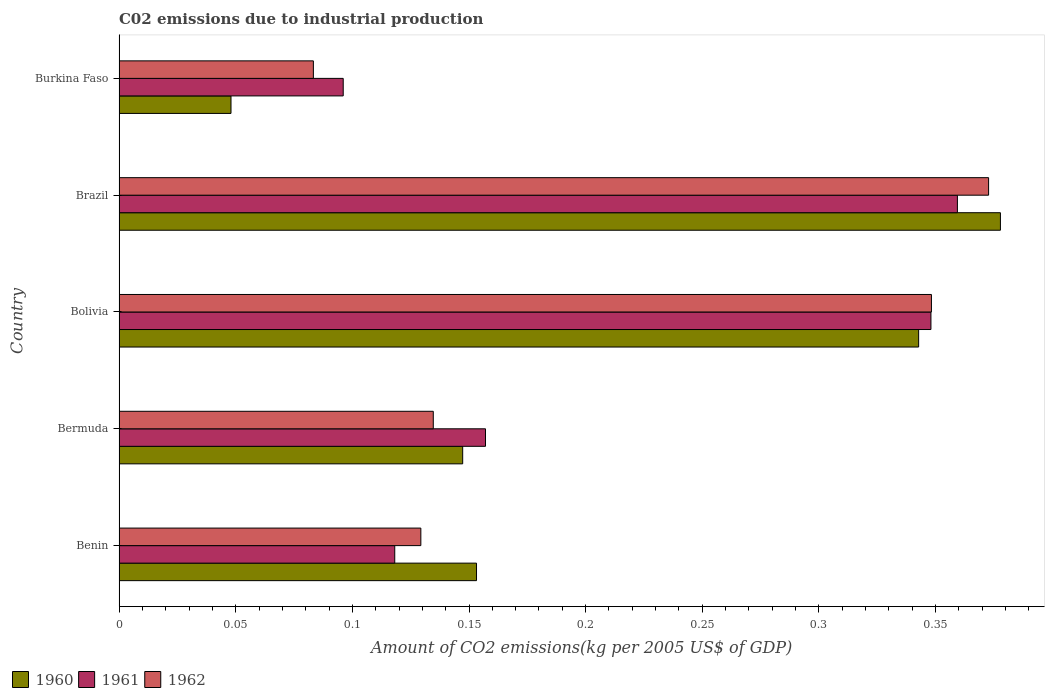How many different coloured bars are there?
Ensure brevity in your answer.  3. How many groups of bars are there?
Your answer should be very brief. 5. Are the number of bars on each tick of the Y-axis equal?
Your answer should be very brief. Yes. How many bars are there on the 4th tick from the top?
Keep it short and to the point. 3. What is the amount of CO2 emitted due to industrial production in 1962 in Bolivia?
Your answer should be very brief. 0.35. Across all countries, what is the maximum amount of CO2 emitted due to industrial production in 1962?
Give a very brief answer. 0.37. Across all countries, what is the minimum amount of CO2 emitted due to industrial production in 1961?
Provide a short and direct response. 0.1. In which country was the amount of CO2 emitted due to industrial production in 1960 minimum?
Offer a terse response. Burkina Faso. What is the total amount of CO2 emitted due to industrial production in 1962 in the graph?
Offer a very short reply. 1.07. What is the difference between the amount of CO2 emitted due to industrial production in 1962 in Benin and that in Burkina Faso?
Offer a terse response. 0.05. What is the difference between the amount of CO2 emitted due to industrial production in 1960 in Bolivia and the amount of CO2 emitted due to industrial production in 1962 in Bermuda?
Offer a very short reply. 0.21. What is the average amount of CO2 emitted due to industrial production in 1962 per country?
Ensure brevity in your answer.  0.21. What is the difference between the amount of CO2 emitted due to industrial production in 1961 and amount of CO2 emitted due to industrial production in 1962 in Bolivia?
Your answer should be very brief. -0. What is the ratio of the amount of CO2 emitted due to industrial production in 1960 in Benin to that in Burkina Faso?
Keep it short and to the point. 3.19. What is the difference between the highest and the second highest amount of CO2 emitted due to industrial production in 1961?
Your answer should be very brief. 0.01. What is the difference between the highest and the lowest amount of CO2 emitted due to industrial production in 1961?
Your answer should be very brief. 0.26. In how many countries, is the amount of CO2 emitted due to industrial production in 1961 greater than the average amount of CO2 emitted due to industrial production in 1961 taken over all countries?
Your answer should be very brief. 2. Is the sum of the amount of CO2 emitted due to industrial production in 1961 in Benin and Burkina Faso greater than the maximum amount of CO2 emitted due to industrial production in 1962 across all countries?
Make the answer very short. No. What does the 1st bar from the top in Benin represents?
Make the answer very short. 1962. Does the graph contain any zero values?
Make the answer very short. No. Where does the legend appear in the graph?
Make the answer very short. Bottom left. What is the title of the graph?
Your response must be concise. C02 emissions due to industrial production. What is the label or title of the X-axis?
Your response must be concise. Amount of CO2 emissions(kg per 2005 US$ of GDP). What is the label or title of the Y-axis?
Provide a succinct answer. Country. What is the Amount of CO2 emissions(kg per 2005 US$ of GDP) of 1960 in Benin?
Your answer should be compact. 0.15. What is the Amount of CO2 emissions(kg per 2005 US$ of GDP) of 1961 in Benin?
Provide a short and direct response. 0.12. What is the Amount of CO2 emissions(kg per 2005 US$ of GDP) of 1962 in Benin?
Give a very brief answer. 0.13. What is the Amount of CO2 emissions(kg per 2005 US$ of GDP) in 1960 in Bermuda?
Make the answer very short. 0.15. What is the Amount of CO2 emissions(kg per 2005 US$ of GDP) in 1961 in Bermuda?
Your answer should be compact. 0.16. What is the Amount of CO2 emissions(kg per 2005 US$ of GDP) in 1962 in Bermuda?
Provide a short and direct response. 0.13. What is the Amount of CO2 emissions(kg per 2005 US$ of GDP) of 1960 in Bolivia?
Ensure brevity in your answer.  0.34. What is the Amount of CO2 emissions(kg per 2005 US$ of GDP) of 1961 in Bolivia?
Your answer should be compact. 0.35. What is the Amount of CO2 emissions(kg per 2005 US$ of GDP) in 1962 in Bolivia?
Make the answer very short. 0.35. What is the Amount of CO2 emissions(kg per 2005 US$ of GDP) of 1960 in Brazil?
Your answer should be compact. 0.38. What is the Amount of CO2 emissions(kg per 2005 US$ of GDP) in 1961 in Brazil?
Provide a short and direct response. 0.36. What is the Amount of CO2 emissions(kg per 2005 US$ of GDP) in 1962 in Brazil?
Offer a terse response. 0.37. What is the Amount of CO2 emissions(kg per 2005 US$ of GDP) of 1960 in Burkina Faso?
Provide a succinct answer. 0.05. What is the Amount of CO2 emissions(kg per 2005 US$ of GDP) of 1961 in Burkina Faso?
Offer a terse response. 0.1. What is the Amount of CO2 emissions(kg per 2005 US$ of GDP) in 1962 in Burkina Faso?
Ensure brevity in your answer.  0.08. Across all countries, what is the maximum Amount of CO2 emissions(kg per 2005 US$ of GDP) of 1960?
Offer a terse response. 0.38. Across all countries, what is the maximum Amount of CO2 emissions(kg per 2005 US$ of GDP) in 1961?
Keep it short and to the point. 0.36. Across all countries, what is the maximum Amount of CO2 emissions(kg per 2005 US$ of GDP) in 1962?
Give a very brief answer. 0.37. Across all countries, what is the minimum Amount of CO2 emissions(kg per 2005 US$ of GDP) of 1960?
Make the answer very short. 0.05. Across all countries, what is the minimum Amount of CO2 emissions(kg per 2005 US$ of GDP) in 1961?
Offer a very short reply. 0.1. Across all countries, what is the minimum Amount of CO2 emissions(kg per 2005 US$ of GDP) in 1962?
Provide a succinct answer. 0.08. What is the total Amount of CO2 emissions(kg per 2005 US$ of GDP) of 1960 in the graph?
Your answer should be very brief. 1.07. What is the total Amount of CO2 emissions(kg per 2005 US$ of GDP) of 1961 in the graph?
Your response must be concise. 1.08. What is the total Amount of CO2 emissions(kg per 2005 US$ of GDP) in 1962 in the graph?
Ensure brevity in your answer.  1.07. What is the difference between the Amount of CO2 emissions(kg per 2005 US$ of GDP) in 1960 in Benin and that in Bermuda?
Make the answer very short. 0.01. What is the difference between the Amount of CO2 emissions(kg per 2005 US$ of GDP) of 1961 in Benin and that in Bermuda?
Offer a terse response. -0.04. What is the difference between the Amount of CO2 emissions(kg per 2005 US$ of GDP) of 1962 in Benin and that in Bermuda?
Provide a short and direct response. -0.01. What is the difference between the Amount of CO2 emissions(kg per 2005 US$ of GDP) of 1960 in Benin and that in Bolivia?
Provide a succinct answer. -0.19. What is the difference between the Amount of CO2 emissions(kg per 2005 US$ of GDP) in 1961 in Benin and that in Bolivia?
Offer a very short reply. -0.23. What is the difference between the Amount of CO2 emissions(kg per 2005 US$ of GDP) in 1962 in Benin and that in Bolivia?
Your answer should be very brief. -0.22. What is the difference between the Amount of CO2 emissions(kg per 2005 US$ of GDP) of 1960 in Benin and that in Brazil?
Your answer should be very brief. -0.22. What is the difference between the Amount of CO2 emissions(kg per 2005 US$ of GDP) in 1961 in Benin and that in Brazil?
Give a very brief answer. -0.24. What is the difference between the Amount of CO2 emissions(kg per 2005 US$ of GDP) of 1962 in Benin and that in Brazil?
Your answer should be very brief. -0.24. What is the difference between the Amount of CO2 emissions(kg per 2005 US$ of GDP) of 1960 in Benin and that in Burkina Faso?
Offer a very short reply. 0.11. What is the difference between the Amount of CO2 emissions(kg per 2005 US$ of GDP) of 1961 in Benin and that in Burkina Faso?
Your answer should be very brief. 0.02. What is the difference between the Amount of CO2 emissions(kg per 2005 US$ of GDP) of 1962 in Benin and that in Burkina Faso?
Provide a short and direct response. 0.05. What is the difference between the Amount of CO2 emissions(kg per 2005 US$ of GDP) in 1960 in Bermuda and that in Bolivia?
Your answer should be compact. -0.2. What is the difference between the Amount of CO2 emissions(kg per 2005 US$ of GDP) of 1961 in Bermuda and that in Bolivia?
Ensure brevity in your answer.  -0.19. What is the difference between the Amount of CO2 emissions(kg per 2005 US$ of GDP) in 1962 in Bermuda and that in Bolivia?
Make the answer very short. -0.21. What is the difference between the Amount of CO2 emissions(kg per 2005 US$ of GDP) in 1960 in Bermuda and that in Brazil?
Give a very brief answer. -0.23. What is the difference between the Amount of CO2 emissions(kg per 2005 US$ of GDP) of 1961 in Bermuda and that in Brazil?
Make the answer very short. -0.2. What is the difference between the Amount of CO2 emissions(kg per 2005 US$ of GDP) in 1962 in Bermuda and that in Brazil?
Offer a very short reply. -0.24. What is the difference between the Amount of CO2 emissions(kg per 2005 US$ of GDP) of 1960 in Bermuda and that in Burkina Faso?
Your response must be concise. 0.1. What is the difference between the Amount of CO2 emissions(kg per 2005 US$ of GDP) of 1961 in Bermuda and that in Burkina Faso?
Your answer should be compact. 0.06. What is the difference between the Amount of CO2 emissions(kg per 2005 US$ of GDP) in 1962 in Bermuda and that in Burkina Faso?
Make the answer very short. 0.05. What is the difference between the Amount of CO2 emissions(kg per 2005 US$ of GDP) in 1960 in Bolivia and that in Brazil?
Your answer should be very brief. -0.04. What is the difference between the Amount of CO2 emissions(kg per 2005 US$ of GDP) in 1961 in Bolivia and that in Brazil?
Give a very brief answer. -0.01. What is the difference between the Amount of CO2 emissions(kg per 2005 US$ of GDP) in 1962 in Bolivia and that in Brazil?
Offer a terse response. -0.02. What is the difference between the Amount of CO2 emissions(kg per 2005 US$ of GDP) of 1960 in Bolivia and that in Burkina Faso?
Your response must be concise. 0.29. What is the difference between the Amount of CO2 emissions(kg per 2005 US$ of GDP) in 1961 in Bolivia and that in Burkina Faso?
Make the answer very short. 0.25. What is the difference between the Amount of CO2 emissions(kg per 2005 US$ of GDP) of 1962 in Bolivia and that in Burkina Faso?
Your answer should be compact. 0.26. What is the difference between the Amount of CO2 emissions(kg per 2005 US$ of GDP) of 1960 in Brazil and that in Burkina Faso?
Provide a succinct answer. 0.33. What is the difference between the Amount of CO2 emissions(kg per 2005 US$ of GDP) of 1961 in Brazil and that in Burkina Faso?
Provide a short and direct response. 0.26. What is the difference between the Amount of CO2 emissions(kg per 2005 US$ of GDP) in 1962 in Brazil and that in Burkina Faso?
Give a very brief answer. 0.29. What is the difference between the Amount of CO2 emissions(kg per 2005 US$ of GDP) in 1960 in Benin and the Amount of CO2 emissions(kg per 2005 US$ of GDP) in 1961 in Bermuda?
Offer a very short reply. -0. What is the difference between the Amount of CO2 emissions(kg per 2005 US$ of GDP) of 1960 in Benin and the Amount of CO2 emissions(kg per 2005 US$ of GDP) of 1962 in Bermuda?
Make the answer very short. 0.02. What is the difference between the Amount of CO2 emissions(kg per 2005 US$ of GDP) of 1961 in Benin and the Amount of CO2 emissions(kg per 2005 US$ of GDP) of 1962 in Bermuda?
Give a very brief answer. -0.02. What is the difference between the Amount of CO2 emissions(kg per 2005 US$ of GDP) of 1960 in Benin and the Amount of CO2 emissions(kg per 2005 US$ of GDP) of 1961 in Bolivia?
Offer a very short reply. -0.19. What is the difference between the Amount of CO2 emissions(kg per 2005 US$ of GDP) in 1960 in Benin and the Amount of CO2 emissions(kg per 2005 US$ of GDP) in 1962 in Bolivia?
Give a very brief answer. -0.2. What is the difference between the Amount of CO2 emissions(kg per 2005 US$ of GDP) of 1961 in Benin and the Amount of CO2 emissions(kg per 2005 US$ of GDP) of 1962 in Bolivia?
Provide a short and direct response. -0.23. What is the difference between the Amount of CO2 emissions(kg per 2005 US$ of GDP) in 1960 in Benin and the Amount of CO2 emissions(kg per 2005 US$ of GDP) in 1961 in Brazil?
Your answer should be very brief. -0.21. What is the difference between the Amount of CO2 emissions(kg per 2005 US$ of GDP) of 1960 in Benin and the Amount of CO2 emissions(kg per 2005 US$ of GDP) of 1962 in Brazil?
Your answer should be compact. -0.22. What is the difference between the Amount of CO2 emissions(kg per 2005 US$ of GDP) of 1961 in Benin and the Amount of CO2 emissions(kg per 2005 US$ of GDP) of 1962 in Brazil?
Give a very brief answer. -0.25. What is the difference between the Amount of CO2 emissions(kg per 2005 US$ of GDP) in 1960 in Benin and the Amount of CO2 emissions(kg per 2005 US$ of GDP) in 1961 in Burkina Faso?
Offer a terse response. 0.06. What is the difference between the Amount of CO2 emissions(kg per 2005 US$ of GDP) in 1960 in Benin and the Amount of CO2 emissions(kg per 2005 US$ of GDP) in 1962 in Burkina Faso?
Make the answer very short. 0.07. What is the difference between the Amount of CO2 emissions(kg per 2005 US$ of GDP) in 1961 in Benin and the Amount of CO2 emissions(kg per 2005 US$ of GDP) in 1962 in Burkina Faso?
Offer a terse response. 0.03. What is the difference between the Amount of CO2 emissions(kg per 2005 US$ of GDP) of 1960 in Bermuda and the Amount of CO2 emissions(kg per 2005 US$ of GDP) of 1961 in Bolivia?
Your response must be concise. -0.2. What is the difference between the Amount of CO2 emissions(kg per 2005 US$ of GDP) in 1960 in Bermuda and the Amount of CO2 emissions(kg per 2005 US$ of GDP) in 1962 in Bolivia?
Provide a short and direct response. -0.2. What is the difference between the Amount of CO2 emissions(kg per 2005 US$ of GDP) of 1961 in Bermuda and the Amount of CO2 emissions(kg per 2005 US$ of GDP) of 1962 in Bolivia?
Ensure brevity in your answer.  -0.19. What is the difference between the Amount of CO2 emissions(kg per 2005 US$ of GDP) of 1960 in Bermuda and the Amount of CO2 emissions(kg per 2005 US$ of GDP) of 1961 in Brazil?
Keep it short and to the point. -0.21. What is the difference between the Amount of CO2 emissions(kg per 2005 US$ of GDP) in 1960 in Bermuda and the Amount of CO2 emissions(kg per 2005 US$ of GDP) in 1962 in Brazil?
Keep it short and to the point. -0.23. What is the difference between the Amount of CO2 emissions(kg per 2005 US$ of GDP) of 1961 in Bermuda and the Amount of CO2 emissions(kg per 2005 US$ of GDP) of 1962 in Brazil?
Your answer should be very brief. -0.22. What is the difference between the Amount of CO2 emissions(kg per 2005 US$ of GDP) of 1960 in Bermuda and the Amount of CO2 emissions(kg per 2005 US$ of GDP) of 1961 in Burkina Faso?
Provide a succinct answer. 0.05. What is the difference between the Amount of CO2 emissions(kg per 2005 US$ of GDP) of 1960 in Bermuda and the Amount of CO2 emissions(kg per 2005 US$ of GDP) of 1962 in Burkina Faso?
Ensure brevity in your answer.  0.06. What is the difference between the Amount of CO2 emissions(kg per 2005 US$ of GDP) of 1961 in Bermuda and the Amount of CO2 emissions(kg per 2005 US$ of GDP) of 1962 in Burkina Faso?
Give a very brief answer. 0.07. What is the difference between the Amount of CO2 emissions(kg per 2005 US$ of GDP) of 1960 in Bolivia and the Amount of CO2 emissions(kg per 2005 US$ of GDP) of 1961 in Brazil?
Keep it short and to the point. -0.02. What is the difference between the Amount of CO2 emissions(kg per 2005 US$ of GDP) in 1960 in Bolivia and the Amount of CO2 emissions(kg per 2005 US$ of GDP) in 1962 in Brazil?
Provide a succinct answer. -0.03. What is the difference between the Amount of CO2 emissions(kg per 2005 US$ of GDP) in 1961 in Bolivia and the Amount of CO2 emissions(kg per 2005 US$ of GDP) in 1962 in Brazil?
Your response must be concise. -0.02. What is the difference between the Amount of CO2 emissions(kg per 2005 US$ of GDP) of 1960 in Bolivia and the Amount of CO2 emissions(kg per 2005 US$ of GDP) of 1961 in Burkina Faso?
Offer a terse response. 0.25. What is the difference between the Amount of CO2 emissions(kg per 2005 US$ of GDP) in 1960 in Bolivia and the Amount of CO2 emissions(kg per 2005 US$ of GDP) in 1962 in Burkina Faso?
Provide a short and direct response. 0.26. What is the difference between the Amount of CO2 emissions(kg per 2005 US$ of GDP) of 1961 in Bolivia and the Amount of CO2 emissions(kg per 2005 US$ of GDP) of 1962 in Burkina Faso?
Provide a short and direct response. 0.26. What is the difference between the Amount of CO2 emissions(kg per 2005 US$ of GDP) in 1960 in Brazil and the Amount of CO2 emissions(kg per 2005 US$ of GDP) in 1961 in Burkina Faso?
Offer a very short reply. 0.28. What is the difference between the Amount of CO2 emissions(kg per 2005 US$ of GDP) in 1960 in Brazil and the Amount of CO2 emissions(kg per 2005 US$ of GDP) in 1962 in Burkina Faso?
Keep it short and to the point. 0.29. What is the difference between the Amount of CO2 emissions(kg per 2005 US$ of GDP) of 1961 in Brazil and the Amount of CO2 emissions(kg per 2005 US$ of GDP) of 1962 in Burkina Faso?
Keep it short and to the point. 0.28. What is the average Amount of CO2 emissions(kg per 2005 US$ of GDP) of 1960 per country?
Your answer should be very brief. 0.21. What is the average Amount of CO2 emissions(kg per 2005 US$ of GDP) in 1961 per country?
Your answer should be compact. 0.22. What is the average Amount of CO2 emissions(kg per 2005 US$ of GDP) in 1962 per country?
Offer a very short reply. 0.21. What is the difference between the Amount of CO2 emissions(kg per 2005 US$ of GDP) of 1960 and Amount of CO2 emissions(kg per 2005 US$ of GDP) of 1961 in Benin?
Make the answer very short. 0.04. What is the difference between the Amount of CO2 emissions(kg per 2005 US$ of GDP) of 1960 and Amount of CO2 emissions(kg per 2005 US$ of GDP) of 1962 in Benin?
Give a very brief answer. 0.02. What is the difference between the Amount of CO2 emissions(kg per 2005 US$ of GDP) of 1961 and Amount of CO2 emissions(kg per 2005 US$ of GDP) of 1962 in Benin?
Offer a very short reply. -0.01. What is the difference between the Amount of CO2 emissions(kg per 2005 US$ of GDP) of 1960 and Amount of CO2 emissions(kg per 2005 US$ of GDP) of 1961 in Bermuda?
Your answer should be very brief. -0.01. What is the difference between the Amount of CO2 emissions(kg per 2005 US$ of GDP) of 1960 and Amount of CO2 emissions(kg per 2005 US$ of GDP) of 1962 in Bermuda?
Offer a terse response. 0.01. What is the difference between the Amount of CO2 emissions(kg per 2005 US$ of GDP) in 1961 and Amount of CO2 emissions(kg per 2005 US$ of GDP) in 1962 in Bermuda?
Offer a very short reply. 0.02. What is the difference between the Amount of CO2 emissions(kg per 2005 US$ of GDP) of 1960 and Amount of CO2 emissions(kg per 2005 US$ of GDP) of 1961 in Bolivia?
Keep it short and to the point. -0.01. What is the difference between the Amount of CO2 emissions(kg per 2005 US$ of GDP) in 1960 and Amount of CO2 emissions(kg per 2005 US$ of GDP) in 1962 in Bolivia?
Offer a very short reply. -0.01. What is the difference between the Amount of CO2 emissions(kg per 2005 US$ of GDP) in 1961 and Amount of CO2 emissions(kg per 2005 US$ of GDP) in 1962 in Bolivia?
Provide a short and direct response. -0. What is the difference between the Amount of CO2 emissions(kg per 2005 US$ of GDP) in 1960 and Amount of CO2 emissions(kg per 2005 US$ of GDP) in 1961 in Brazil?
Ensure brevity in your answer.  0.02. What is the difference between the Amount of CO2 emissions(kg per 2005 US$ of GDP) of 1960 and Amount of CO2 emissions(kg per 2005 US$ of GDP) of 1962 in Brazil?
Provide a succinct answer. 0.01. What is the difference between the Amount of CO2 emissions(kg per 2005 US$ of GDP) of 1961 and Amount of CO2 emissions(kg per 2005 US$ of GDP) of 1962 in Brazil?
Give a very brief answer. -0.01. What is the difference between the Amount of CO2 emissions(kg per 2005 US$ of GDP) of 1960 and Amount of CO2 emissions(kg per 2005 US$ of GDP) of 1961 in Burkina Faso?
Offer a terse response. -0.05. What is the difference between the Amount of CO2 emissions(kg per 2005 US$ of GDP) of 1960 and Amount of CO2 emissions(kg per 2005 US$ of GDP) of 1962 in Burkina Faso?
Provide a succinct answer. -0.04. What is the difference between the Amount of CO2 emissions(kg per 2005 US$ of GDP) in 1961 and Amount of CO2 emissions(kg per 2005 US$ of GDP) in 1962 in Burkina Faso?
Your answer should be compact. 0.01. What is the ratio of the Amount of CO2 emissions(kg per 2005 US$ of GDP) of 1960 in Benin to that in Bermuda?
Offer a very short reply. 1.04. What is the ratio of the Amount of CO2 emissions(kg per 2005 US$ of GDP) of 1961 in Benin to that in Bermuda?
Provide a short and direct response. 0.75. What is the ratio of the Amount of CO2 emissions(kg per 2005 US$ of GDP) in 1962 in Benin to that in Bermuda?
Provide a short and direct response. 0.96. What is the ratio of the Amount of CO2 emissions(kg per 2005 US$ of GDP) of 1960 in Benin to that in Bolivia?
Provide a succinct answer. 0.45. What is the ratio of the Amount of CO2 emissions(kg per 2005 US$ of GDP) in 1961 in Benin to that in Bolivia?
Offer a very short reply. 0.34. What is the ratio of the Amount of CO2 emissions(kg per 2005 US$ of GDP) in 1962 in Benin to that in Bolivia?
Offer a terse response. 0.37. What is the ratio of the Amount of CO2 emissions(kg per 2005 US$ of GDP) in 1960 in Benin to that in Brazil?
Give a very brief answer. 0.41. What is the ratio of the Amount of CO2 emissions(kg per 2005 US$ of GDP) of 1961 in Benin to that in Brazil?
Give a very brief answer. 0.33. What is the ratio of the Amount of CO2 emissions(kg per 2005 US$ of GDP) in 1962 in Benin to that in Brazil?
Give a very brief answer. 0.35. What is the ratio of the Amount of CO2 emissions(kg per 2005 US$ of GDP) in 1960 in Benin to that in Burkina Faso?
Your response must be concise. 3.19. What is the ratio of the Amount of CO2 emissions(kg per 2005 US$ of GDP) of 1961 in Benin to that in Burkina Faso?
Provide a succinct answer. 1.23. What is the ratio of the Amount of CO2 emissions(kg per 2005 US$ of GDP) in 1962 in Benin to that in Burkina Faso?
Offer a terse response. 1.55. What is the ratio of the Amount of CO2 emissions(kg per 2005 US$ of GDP) in 1960 in Bermuda to that in Bolivia?
Keep it short and to the point. 0.43. What is the ratio of the Amount of CO2 emissions(kg per 2005 US$ of GDP) of 1961 in Bermuda to that in Bolivia?
Your answer should be very brief. 0.45. What is the ratio of the Amount of CO2 emissions(kg per 2005 US$ of GDP) of 1962 in Bermuda to that in Bolivia?
Keep it short and to the point. 0.39. What is the ratio of the Amount of CO2 emissions(kg per 2005 US$ of GDP) in 1960 in Bermuda to that in Brazil?
Your answer should be compact. 0.39. What is the ratio of the Amount of CO2 emissions(kg per 2005 US$ of GDP) in 1961 in Bermuda to that in Brazil?
Keep it short and to the point. 0.44. What is the ratio of the Amount of CO2 emissions(kg per 2005 US$ of GDP) of 1962 in Bermuda to that in Brazil?
Provide a short and direct response. 0.36. What is the ratio of the Amount of CO2 emissions(kg per 2005 US$ of GDP) of 1960 in Bermuda to that in Burkina Faso?
Provide a succinct answer. 3.07. What is the ratio of the Amount of CO2 emissions(kg per 2005 US$ of GDP) in 1961 in Bermuda to that in Burkina Faso?
Ensure brevity in your answer.  1.63. What is the ratio of the Amount of CO2 emissions(kg per 2005 US$ of GDP) of 1962 in Bermuda to that in Burkina Faso?
Ensure brevity in your answer.  1.62. What is the ratio of the Amount of CO2 emissions(kg per 2005 US$ of GDP) in 1960 in Bolivia to that in Brazil?
Your response must be concise. 0.91. What is the ratio of the Amount of CO2 emissions(kg per 2005 US$ of GDP) of 1961 in Bolivia to that in Brazil?
Your answer should be compact. 0.97. What is the ratio of the Amount of CO2 emissions(kg per 2005 US$ of GDP) in 1962 in Bolivia to that in Brazil?
Provide a succinct answer. 0.93. What is the ratio of the Amount of CO2 emissions(kg per 2005 US$ of GDP) in 1960 in Bolivia to that in Burkina Faso?
Your answer should be very brief. 7.14. What is the ratio of the Amount of CO2 emissions(kg per 2005 US$ of GDP) in 1961 in Bolivia to that in Burkina Faso?
Give a very brief answer. 3.62. What is the ratio of the Amount of CO2 emissions(kg per 2005 US$ of GDP) of 1962 in Bolivia to that in Burkina Faso?
Your response must be concise. 4.18. What is the ratio of the Amount of CO2 emissions(kg per 2005 US$ of GDP) of 1960 in Brazil to that in Burkina Faso?
Offer a terse response. 7.87. What is the ratio of the Amount of CO2 emissions(kg per 2005 US$ of GDP) of 1961 in Brazil to that in Burkina Faso?
Ensure brevity in your answer.  3.74. What is the ratio of the Amount of CO2 emissions(kg per 2005 US$ of GDP) in 1962 in Brazil to that in Burkina Faso?
Provide a short and direct response. 4.47. What is the difference between the highest and the second highest Amount of CO2 emissions(kg per 2005 US$ of GDP) of 1960?
Provide a succinct answer. 0.04. What is the difference between the highest and the second highest Amount of CO2 emissions(kg per 2005 US$ of GDP) in 1961?
Offer a terse response. 0.01. What is the difference between the highest and the second highest Amount of CO2 emissions(kg per 2005 US$ of GDP) in 1962?
Your answer should be compact. 0.02. What is the difference between the highest and the lowest Amount of CO2 emissions(kg per 2005 US$ of GDP) in 1960?
Your answer should be very brief. 0.33. What is the difference between the highest and the lowest Amount of CO2 emissions(kg per 2005 US$ of GDP) in 1961?
Your response must be concise. 0.26. What is the difference between the highest and the lowest Amount of CO2 emissions(kg per 2005 US$ of GDP) in 1962?
Offer a terse response. 0.29. 